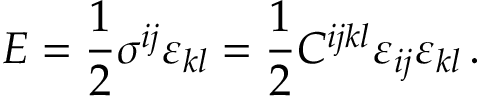<formula> <loc_0><loc_0><loc_500><loc_500>E = \frac { 1 } { 2 } \sigma ^ { i j } \varepsilon _ { k l } = \frac { 1 } { 2 } C ^ { i j k l } \varepsilon _ { i j } \varepsilon _ { k l } \, .</formula> 